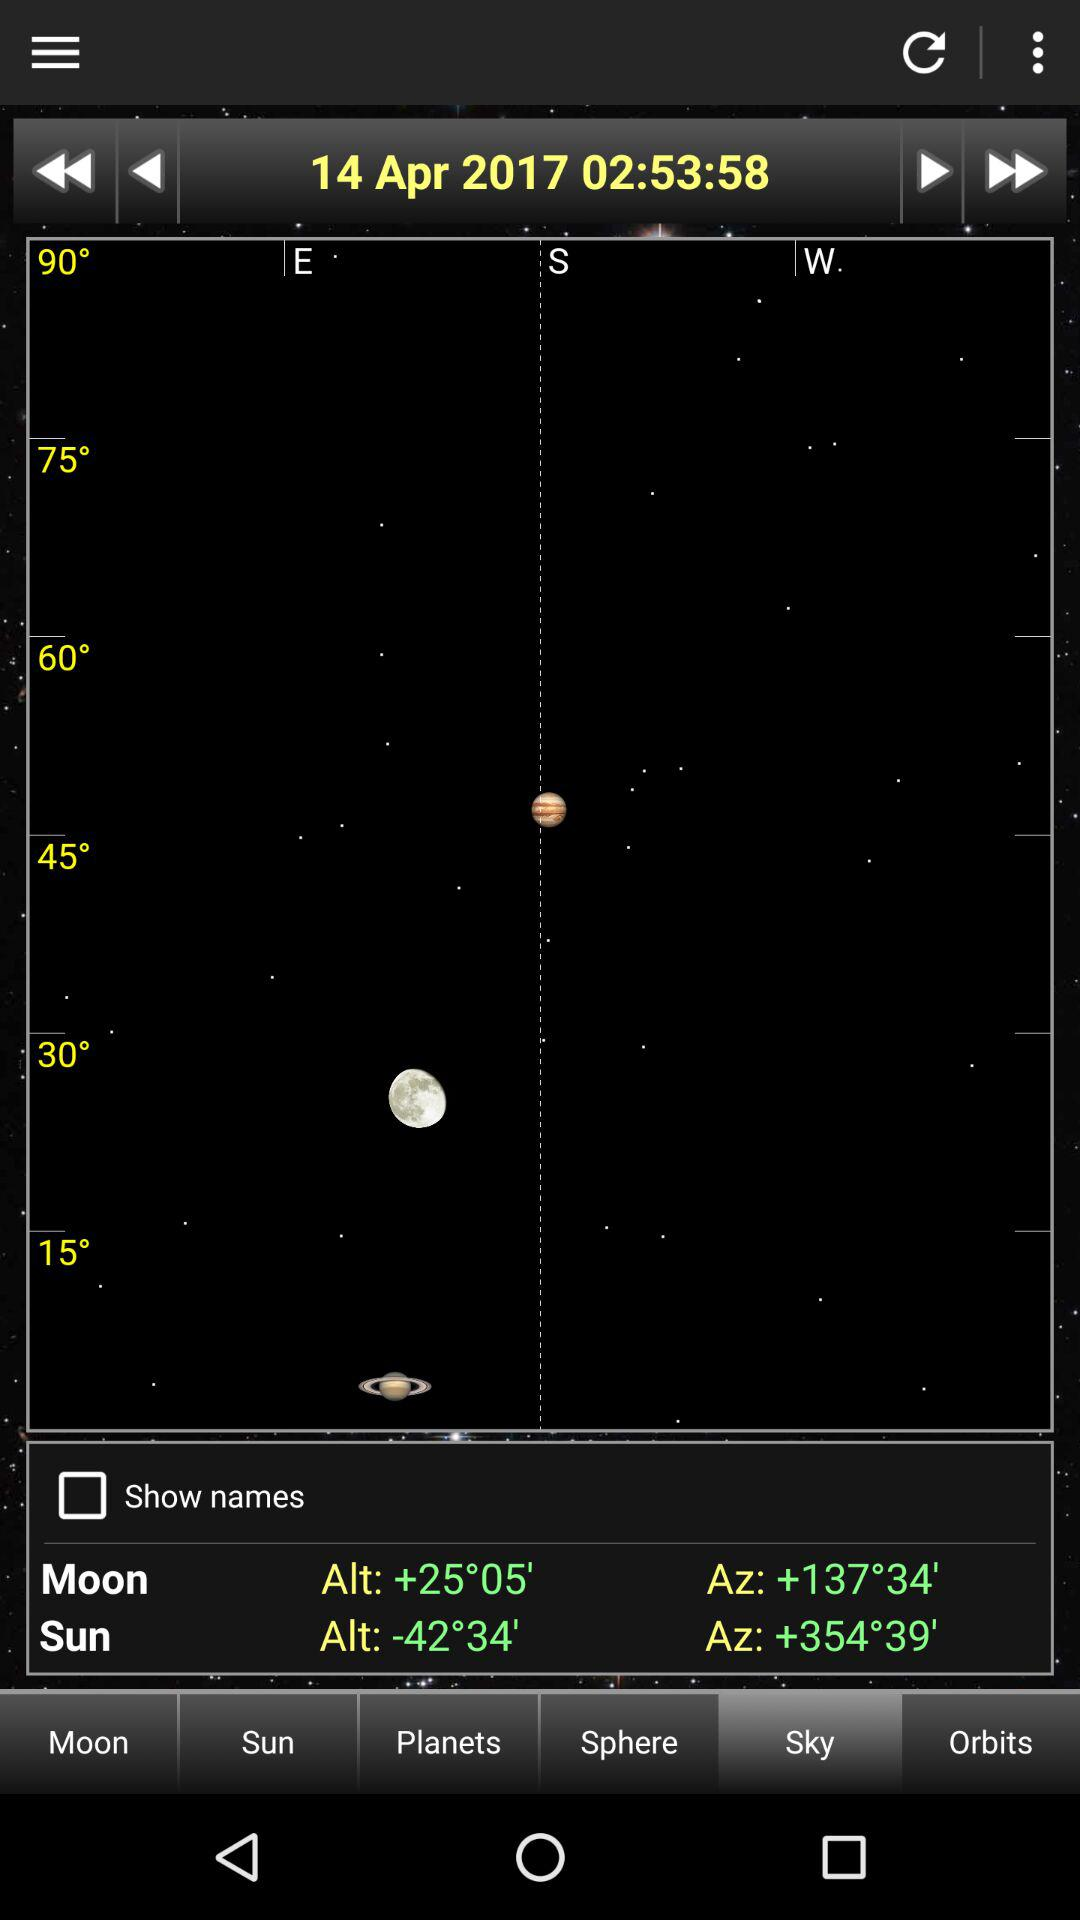What is the time? The time is 02:53:58. 